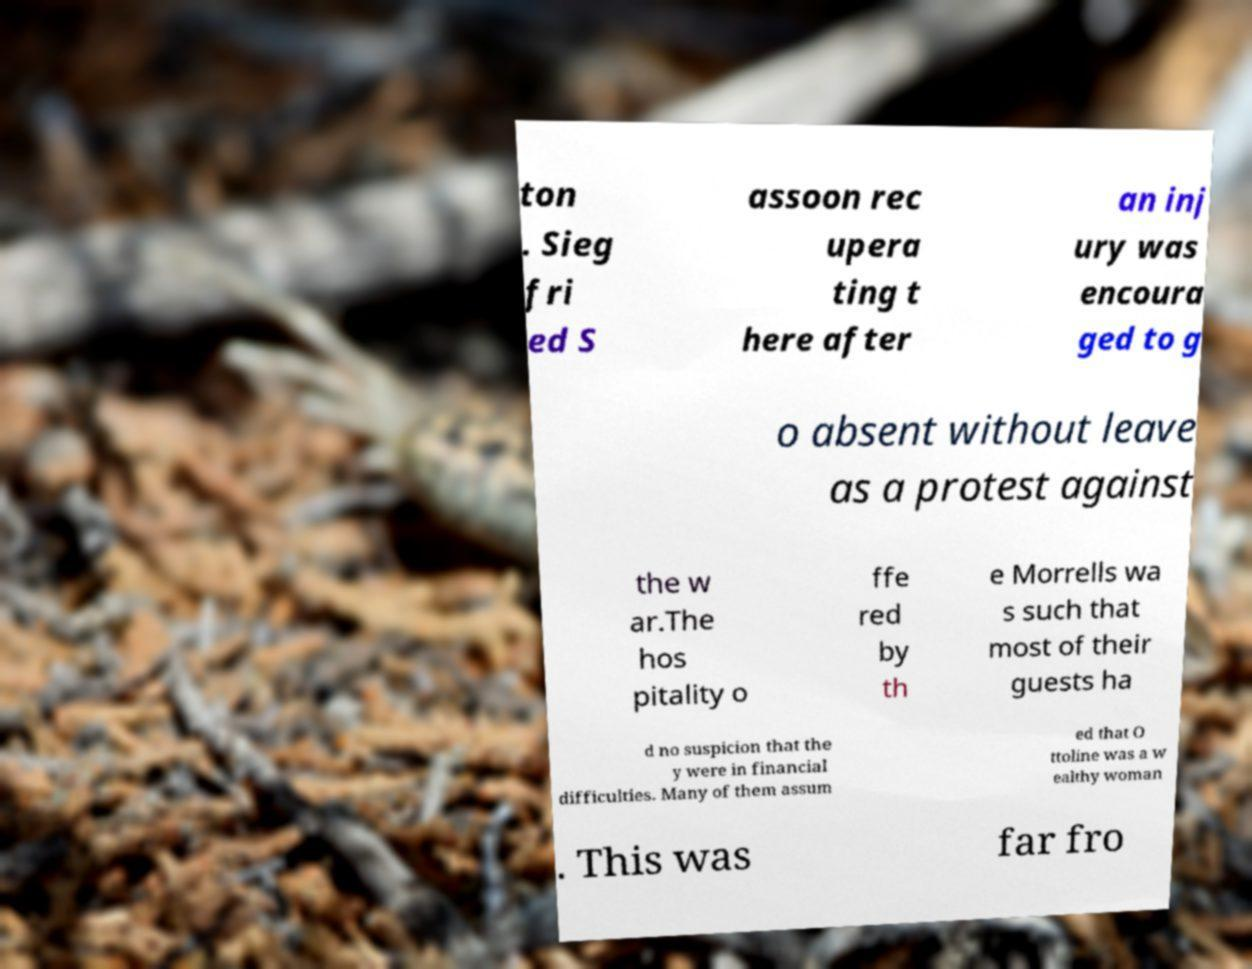Can you accurately transcribe the text from the provided image for me? ton . Sieg fri ed S assoon rec upera ting t here after an inj ury was encoura ged to g o absent without leave as a protest against the w ar.The hos pitality o ffe red by th e Morrells wa s such that most of their guests ha d no suspicion that the y were in financial difficulties. Many of them assum ed that O ttoline was a w ealthy woman . This was far fro 